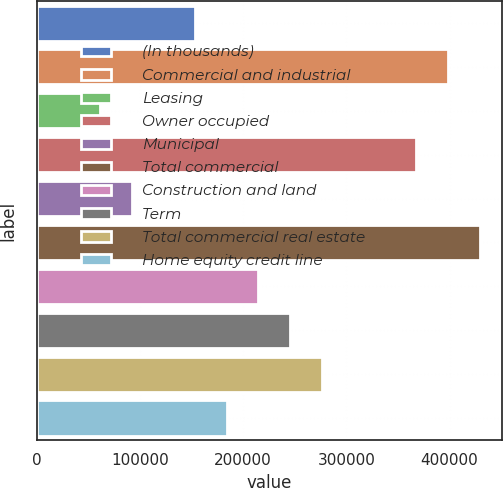Convert chart to OTSL. <chart><loc_0><loc_0><loc_500><loc_500><bar_chart><fcel>(In thousands)<fcel>Commercial and industrial<fcel>Leasing<fcel>Owner occupied<fcel>Municipal<fcel>Total commercial<fcel>Construction and land<fcel>Term<fcel>Total commercial real estate<fcel>Home equity credit line<nl><fcel>153422<fcel>398584<fcel>61486.4<fcel>367938<fcel>92131.6<fcel>429229<fcel>214712<fcel>245358<fcel>276003<fcel>184067<nl></chart> 